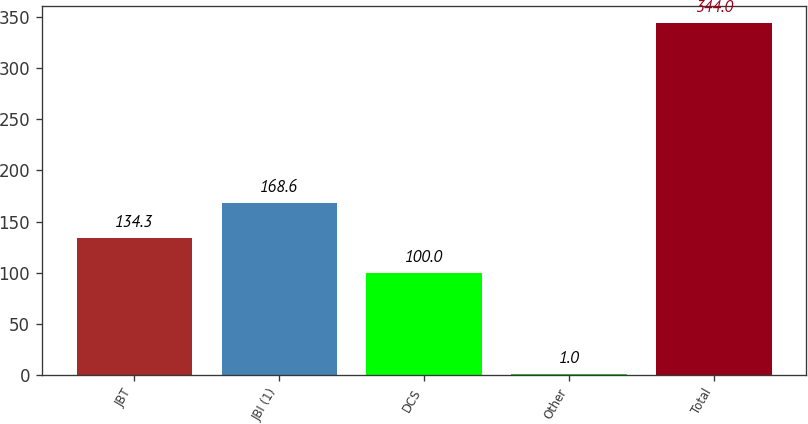Convert chart to OTSL. <chart><loc_0><loc_0><loc_500><loc_500><bar_chart><fcel>JBT<fcel>JBI (1)<fcel>DCS<fcel>Other<fcel>Total<nl><fcel>134.3<fcel>168.6<fcel>100<fcel>1<fcel>344<nl></chart> 